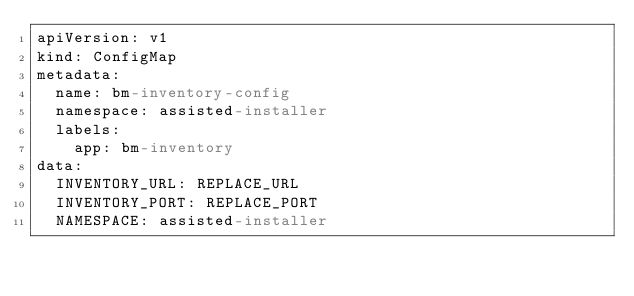Convert code to text. <code><loc_0><loc_0><loc_500><loc_500><_YAML_>apiVersion: v1
kind: ConfigMap
metadata:
  name: bm-inventory-config
  namespace: assisted-installer
  labels:
    app: bm-inventory
data:
  INVENTORY_URL: REPLACE_URL
  INVENTORY_PORT: REPLACE_PORT
  NAMESPACE: assisted-installer
</code> 